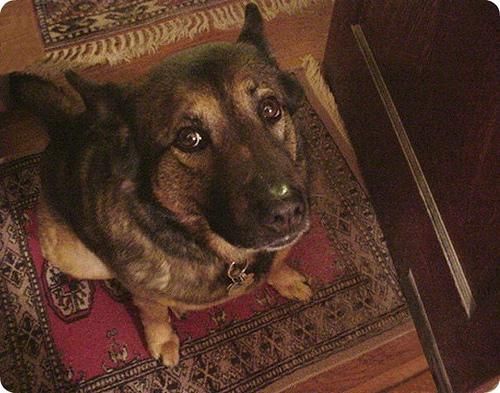Mention the primary focus of the image and what the focus is engaged in. The main focus is a brown dog sitting on a patterned rug, looking at the camera with big brown eyes. List the distinct features of the dog's face and their colors. The distinct features on the dog's face are big brown eyes, small black nose with wet nostrils, pointed back ears, and eyebrows. What is the color of the collar on the dog and what material is it made of? The collar on the dog is black in color and made of metal. Identify the type of flooring in the image and the material used to make the door. The flooring in the image is wooden and the door is made of wood as well. Explain the presence of any accessories on the dog and their characteristics. The dog is wearing a black metal collar with silver dog tags attached to it. How would you describe the dog's eyes and the expression they convey? The dog's eyes are big and brown, giving a begging expression. Identify the type of rug the dog is sitting on and explain the appearance of the rug. The dog is sitting on an oriental rug with red, black, and tan colors, a border pattern, fringe, and a mix of other intricate patterns. Mention the details of the dog's interaction with the camera and its position on the rug. The dog is sitting on the oriental rug, facing and looking into the camera, possibly in a begging expression. Describe the appearance and position of the dog's tail. The dog's tail is long, thick, bushy, and curled. Briefly describe the floor the dog is sitting on and provide essential characteristics of the door in the image. The floor is made of wood and there is a wooden door with a dark brown finish that is partially open. Identify any text present in the image. There is no text in the image. How is the dog's tail positioned? curled Rate the visual quality of the image on a scale of 1 to 10. 8 Which object is described as 'brown dog looking at camera'? X:98 Y:35 Width:232 Height:232 What is the color of the dog's collar? black List the attributes of the dog's nose. small, black, wet, nostrils What type of door is in the image? dark brown wood door Is the rug the dog is sitting on blue and white? No, it's not mentioned in the image. Identify all objects in the image. dog, rug, collar, dog tag, wooden door, floor, dog's nose, dog's eyes, dog's tail, dog's ears, dog's paws What is the pattern on the dog's face? black and tan Describe the interaction between the dog and its environment. The dog is sitting on a rug, attentively looking at the camera, and its tail is curled on the floor. Select the correct color of the rug: blue and yellow, black and tan, or red, black and tan? red, black and tan What is the overall sentiment of the image? positive and warm Is the hardwood floor covered in a polka-dot pattern? There is only one mention of the hardwood floor ("the hardwood floor"), and it doesn't specify any pattern, especially not a polka-dot pattern. Are there any anomalies in the image? If so, describe them. No anomalies detected. What color are the dog's eyes? brown Describe the scene in the image. A dog with big brown eyes and a black collar is sitting on a patterned rug with fringe, looking at the camera. There's an open wooden door in the background. What is the shape of the dog's ears? pointed back Segment the image into its semantic components. dog (sitting, looking at camera), rug (patterned, oriental), collar (black, metal), door (wooden, open), floor (wooden) Identify the material of the door. wood What is the condition of the dog's nose? wet What is the dog doing in the image? sitting on a rug 